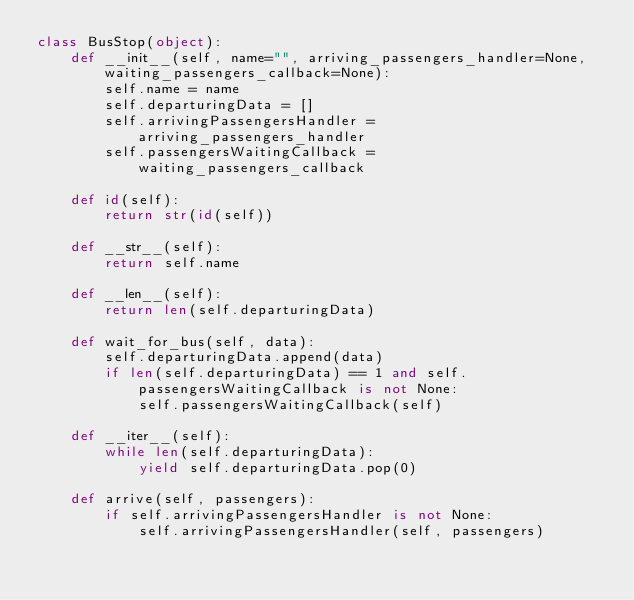Convert code to text. <code><loc_0><loc_0><loc_500><loc_500><_Python_>class BusStop(object):
    def __init__(self, name="", arriving_passengers_handler=None, waiting_passengers_callback=None):
        self.name = name
        self.departuringData = []
        self.arrivingPassengersHandler = arriving_passengers_handler
        self.passengersWaitingCallback = waiting_passengers_callback

    def id(self):
        return str(id(self))

    def __str__(self):
        return self.name

    def __len__(self):
        return len(self.departuringData)

    def wait_for_bus(self, data):
        self.departuringData.append(data)
        if len(self.departuringData) == 1 and self.passengersWaitingCallback is not None:
            self.passengersWaitingCallback(self)

    def __iter__(self):
        while len(self.departuringData):
            yield self.departuringData.pop(0)

    def arrive(self, passengers):
        if self.arrivingPassengersHandler is not None:
            self.arrivingPassengersHandler(self, passengers)
</code> 